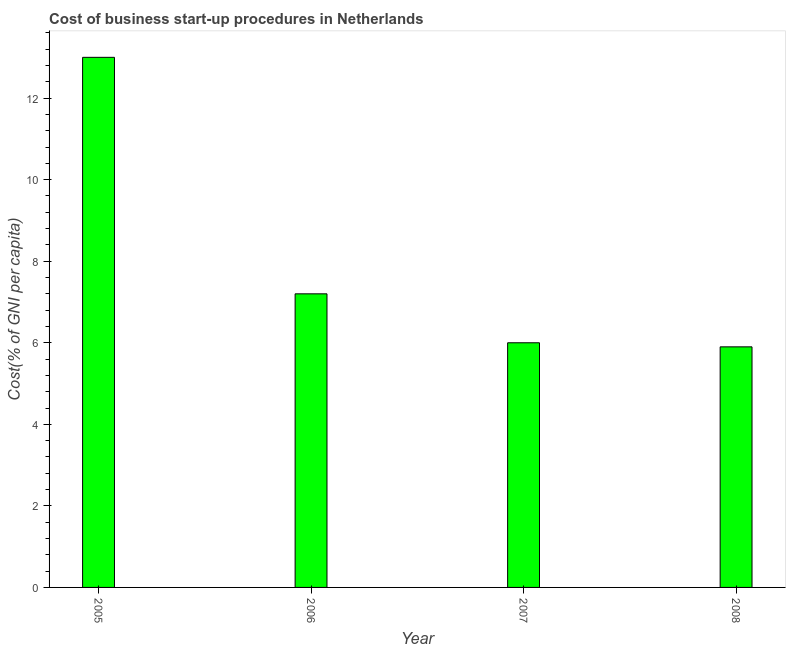Does the graph contain any zero values?
Your answer should be very brief. No. What is the title of the graph?
Your answer should be very brief. Cost of business start-up procedures in Netherlands. What is the label or title of the X-axis?
Make the answer very short. Year. What is the label or title of the Y-axis?
Give a very brief answer. Cost(% of GNI per capita). Across all years, what is the minimum cost of business startup procedures?
Make the answer very short. 5.9. In which year was the cost of business startup procedures maximum?
Provide a short and direct response. 2005. What is the sum of the cost of business startup procedures?
Offer a terse response. 32.1. What is the average cost of business startup procedures per year?
Keep it short and to the point. 8.03. In how many years, is the cost of business startup procedures greater than 3.2 %?
Keep it short and to the point. 4. What is the ratio of the cost of business startup procedures in 2005 to that in 2006?
Keep it short and to the point. 1.81. What is the difference between the highest and the second highest cost of business startup procedures?
Your answer should be compact. 5.8. Is the sum of the cost of business startup procedures in 2006 and 2008 greater than the maximum cost of business startup procedures across all years?
Give a very brief answer. Yes. What is the difference between the highest and the lowest cost of business startup procedures?
Offer a terse response. 7.1. In how many years, is the cost of business startup procedures greater than the average cost of business startup procedures taken over all years?
Offer a very short reply. 1. How many years are there in the graph?
Keep it short and to the point. 4. What is the difference between two consecutive major ticks on the Y-axis?
Provide a short and direct response. 2. What is the Cost(% of GNI per capita) in 2005?
Offer a very short reply. 13. What is the difference between the Cost(% of GNI per capita) in 2005 and 2006?
Offer a very short reply. 5.8. What is the difference between the Cost(% of GNI per capita) in 2006 and 2007?
Provide a succinct answer. 1.2. What is the difference between the Cost(% of GNI per capita) in 2006 and 2008?
Provide a succinct answer. 1.3. What is the difference between the Cost(% of GNI per capita) in 2007 and 2008?
Your answer should be very brief. 0.1. What is the ratio of the Cost(% of GNI per capita) in 2005 to that in 2006?
Keep it short and to the point. 1.81. What is the ratio of the Cost(% of GNI per capita) in 2005 to that in 2007?
Keep it short and to the point. 2.17. What is the ratio of the Cost(% of GNI per capita) in 2005 to that in 2008?
Your answer should be compact. 2.2. What is the ratio of the Cost(% of GNI per capita) in 2006 to that in 2008?
Keep it short and to the point. 1.22. 